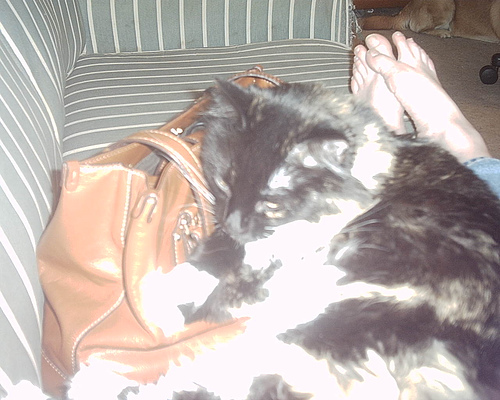Imagine a realistic scenario where the cat is planning a surprise birthday party for its owner. What would that look like? In a realistic scenario, the cat might knock over some objects while trying to get into the pantry for party supplies. It could gather random items around the house, like ribbons, baking paper, and maybe even some treats it found left out. The cat would probably sit by its owner's side, purring as if to say 'Happy birthday!' and enjoying the love and attention in return.  Describe a short realistic scenario involving the cat and the handbag. The cat might be curious about the handbag and sniff around it, trying to peek inside. It could find the leather texture interesting and rub against it before settling down next to it again.  How does the lighting affect the appearance of the cat in the image? The bright lighting causes some parts of the image to be overexposed, making the cat's features appear washed out. This strong light creates high contrast areas, which can obscure the details of the cat's fur and make it look blurry in spots. 